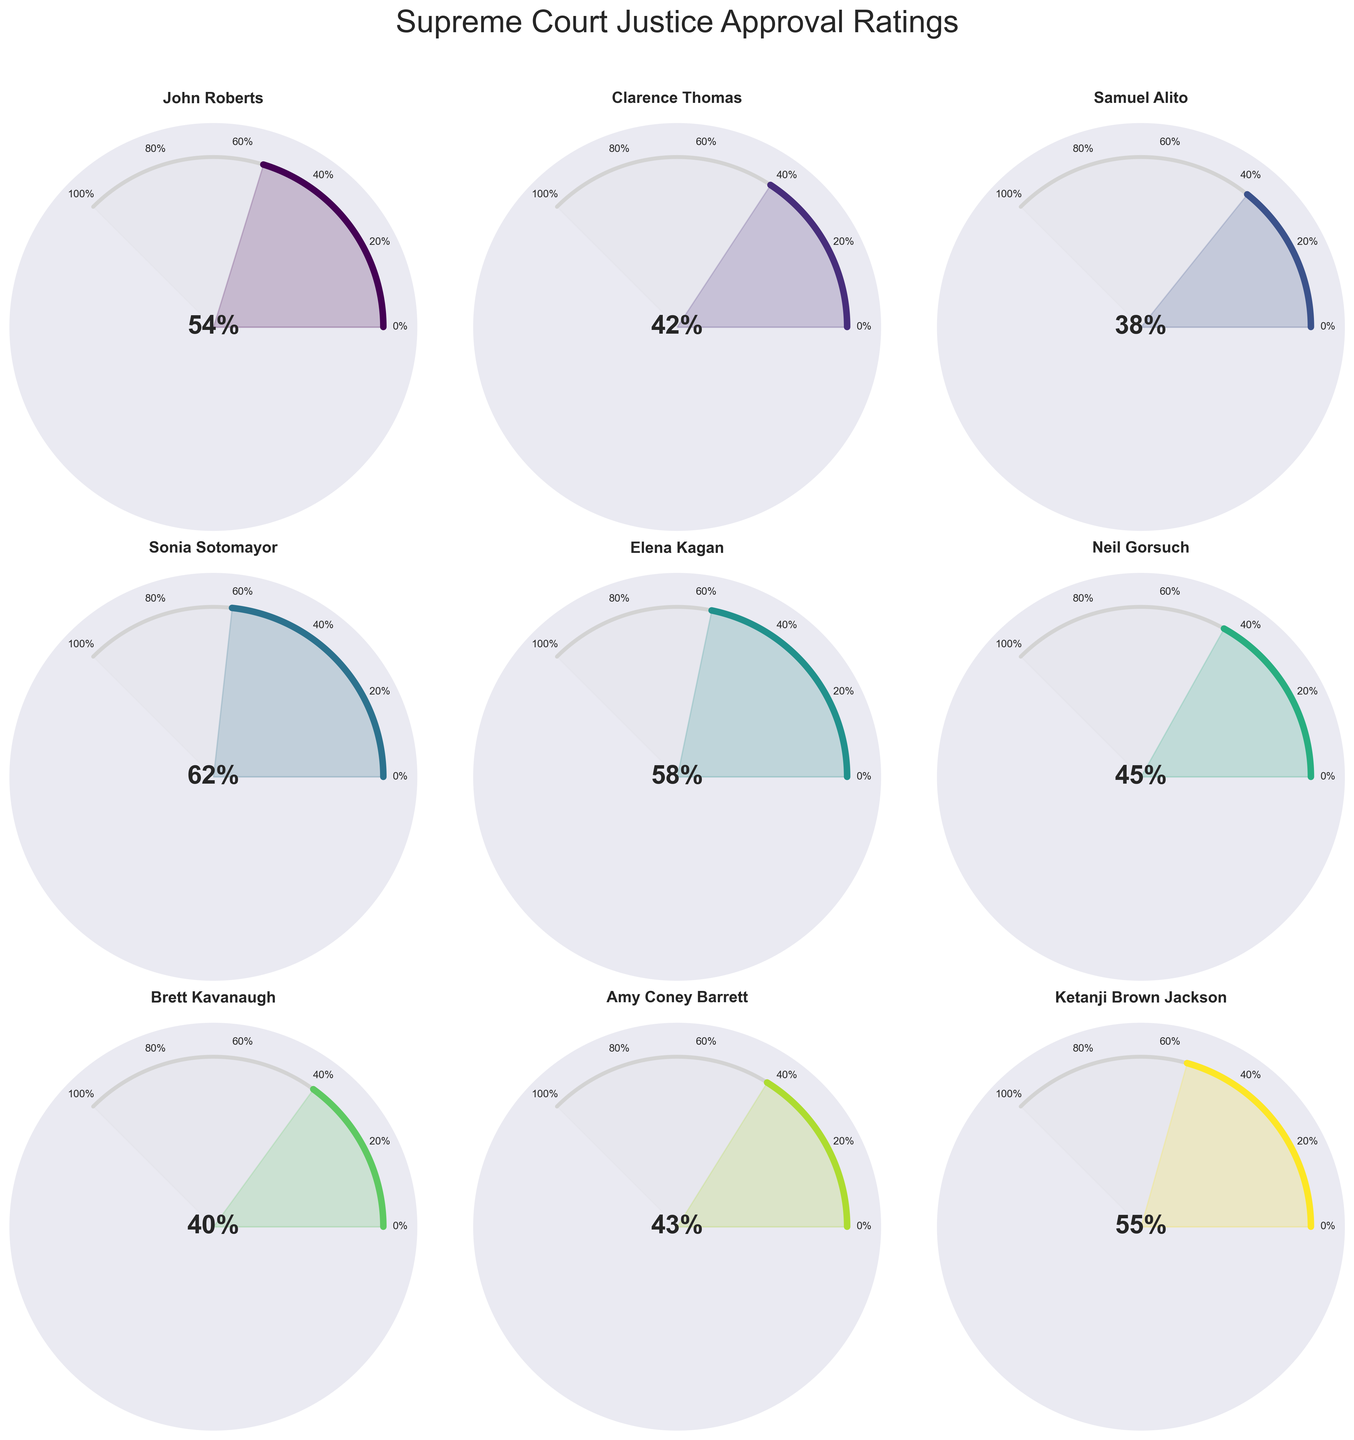What is the approval rating of John Roberts? The figure displays individual gauge charts for each justice. Locate the gauge chart labeled "John Roberts" and read the approval rating directly indicated.
Answer: 54% Which Supreme Court justice has the highest approval rating? Scan through all individual gauge charts and identify the justice with the highest percentage indicated.
Answer: Sonia Sotomayor Which justice has the lowest approval rating? Look through all the gauge charts to find the justice with the lowest indicated percentage.
Answer: Samuel Alito What is the average approval rating of the justices shown? Add up all the approval ratings: (54 + 42 + 38 + 62 + 58 + 45 + 40 + 43 + 55) and divide by the number of justices, which is 9.
Answer: 48.56 How does Neil Gorsuch’s approval rating compare to Brett Kavanaugh’s? Observe the approval ratings for both Neil Gorsuch and Brett Kavanaugh in their respective gauge charts. Compare the two ratings numerically.
Answer: Neil Gorsuch (45%) is higher than Brett Kavanaugh (40%) Which justice has a closer approval rating to Amy Coney Barrett, Sonia Sotomayor or Clarence Thomas? Compare Amy Coney Barrett's rating (43%) to both Sonia Sotomayor's (62%) and Clarence Thomas’s (42%). Determine which rating is numerically closer.
Answer: Clarence Thomas What is the combined approval rating for the justices appointed by Republican presidents? Sum the approval ratings of John Roberts (54), Clarence Thomas (42), Samuel Alito (38), Neil Gorsuch (45), Brett Kavanaugh (40), and Amy Coney Barrett (43).
Answer: 262 How much higher is Elena Kagan's approval rating compared to Samuel Alito's? Subtract Samuel Alito's approval rating (38) from Elena Kagan’s (58).
Answer: 20 What is the range of approval ratings shown in the figure? Subtract the minimum rating (38, Samuel Alito) from the maximum rating (62, Sonia Sotomayor).
Answer: 24 Which justice has an approval rating closest to the median approval rating of all justices? List the approval ratings in ascending order: 38, 40, 42, 43, 45, 54, 55, 58, 62. Determine the median value, which is 45 (Neil Gorsuch) in this 9-point list. Find the justice with an approval rating closest to it.
Answer: Neil Gorsuch 